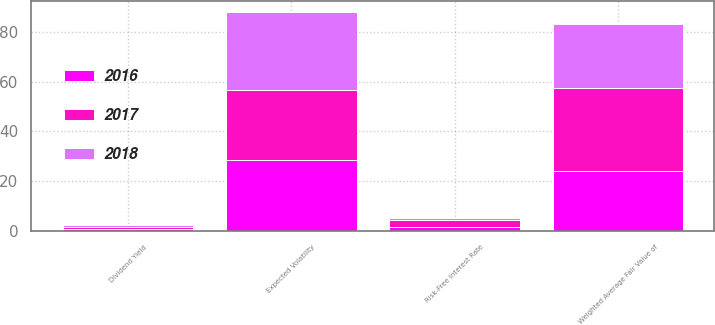<chart> <loc_0><loc_0><loc_500><loc_500><stacked_bar_chart><ecel><fcel>Weighted Average Fair Value of<fcel>Expected Volatility<fcel>Risk-Free Interest Rate<fcel>Dividend Yield<nl><fcel>2017<fcel>33.46<fcel>28.23<fcel>2.68<fcel>0.72<nl><fcel>2016<fcel>23.95<fcel>28.28<fcel>1.52<fcel>0.75<nl><fcel>2018<fcel>25.78<fcel>31.54<fcel>0.78<fcel>0.76<nl></chart> 